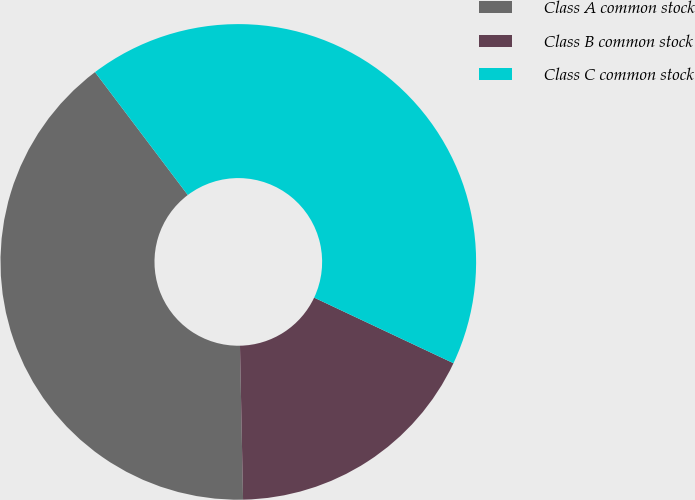Convert chart to OTSL. <chart><loc_0><loc_0><loc_500><loc_500><pie_chart><fcel>Class A common stock<fcel>Class B common stock<fcel>Class C common stock<nl><fcel>40.03%<fcel>17.68%<fcel>42.3%<nl></chart> 